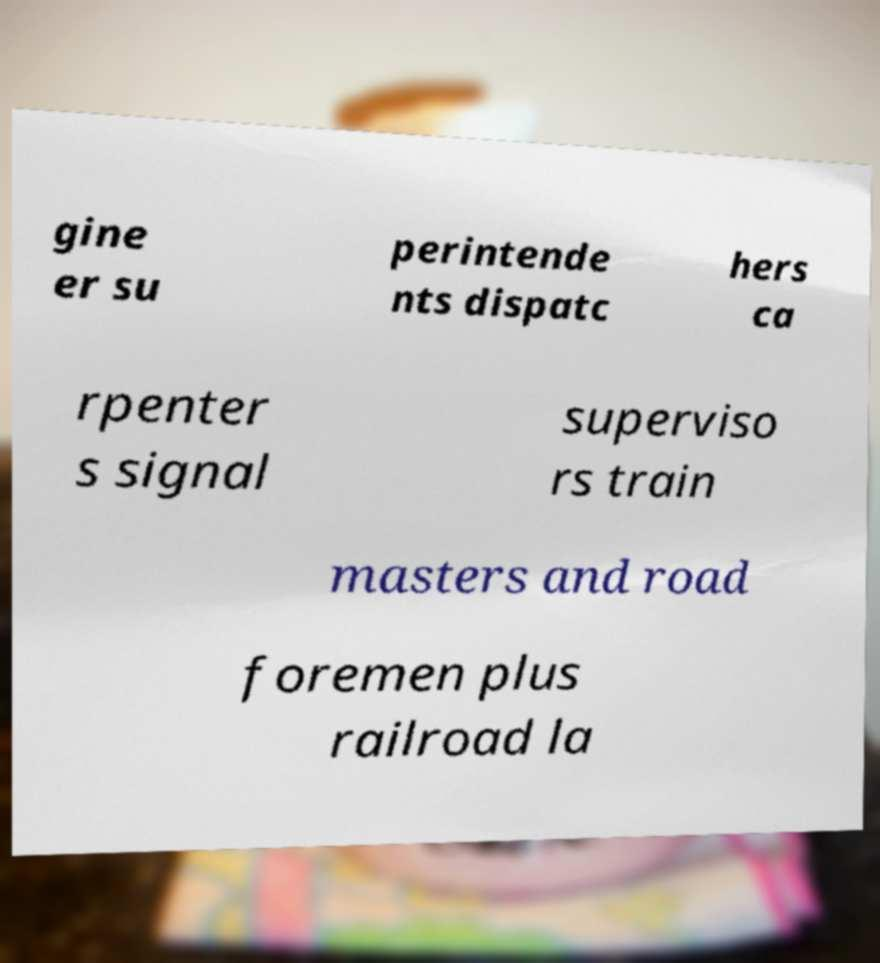Can you accurately transcribe the text from the provided image for me? gine er su perintende nts dispatc hers ca rpenter s signal superviso rs train masters and road foremen plus railroad la 